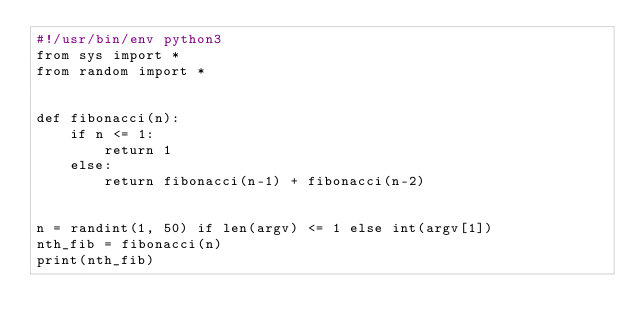<code> <loc_0><loc_0><loc_500><loc_500><_Python_>#!/usr/bin/env python3
from sys import *
from random import *


def fibonacci(n):
    if n <= 1:
        return 1
    else:
        return fibonacci(n-1) + fibonacci(n-2)


n = randint(1, 50) if len(argv) <= 1 else int(argv[1])
nth_fib = fibonacci(n)
print(nth_fib)
</code> 